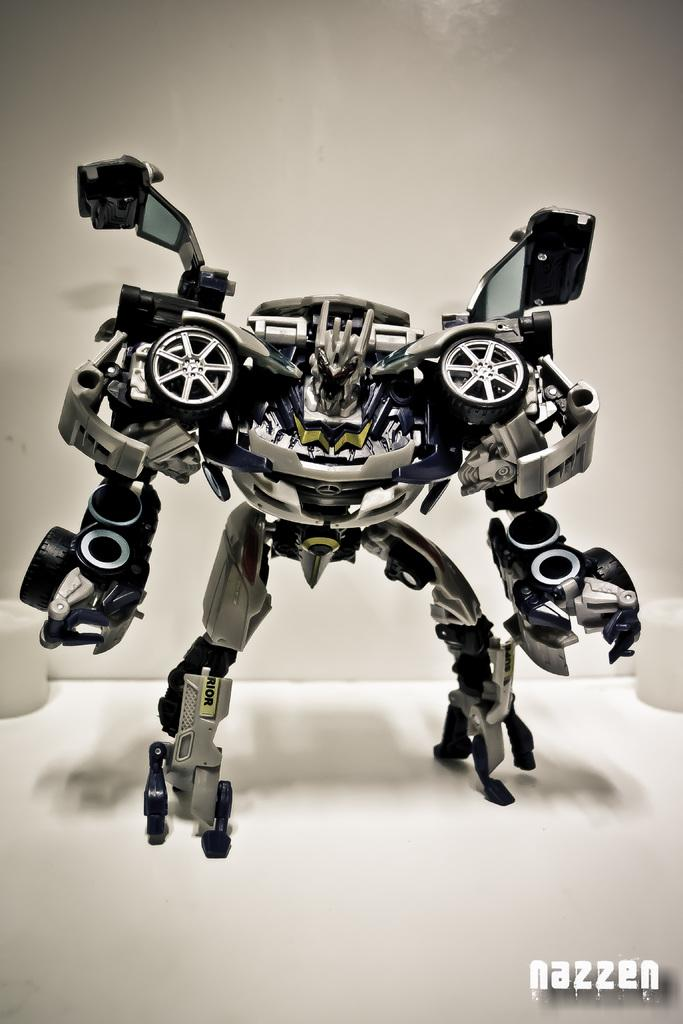What is the main subject in the middle of the image? There is a toy in the middle of the image. Is there any additional information or marking at the bottom right of the image? Yes, there is a watermark at the right bottom of the image. How many pizzas are visible in the image? There are no pizzas present in the image. What type of owl can be seen sitting on the toy in the image? There is no owl present in the image; it only features a toy. 